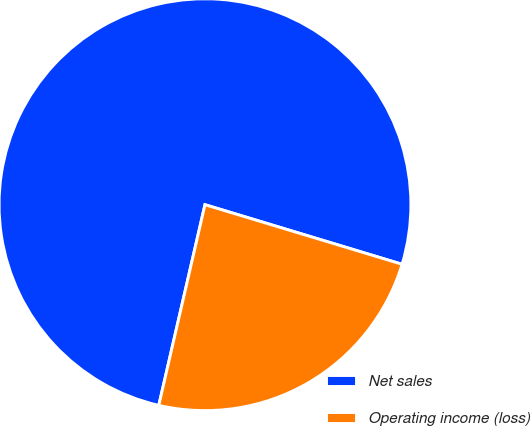Convert chart to OTSL. <chart><loc_0><loc_0><loc_500><loc_500><pie_chart><fcel>Net sales<fcel>Operating income (loss)<nl><fcel>76.07%<fcel>23.93%<nl></chart> 